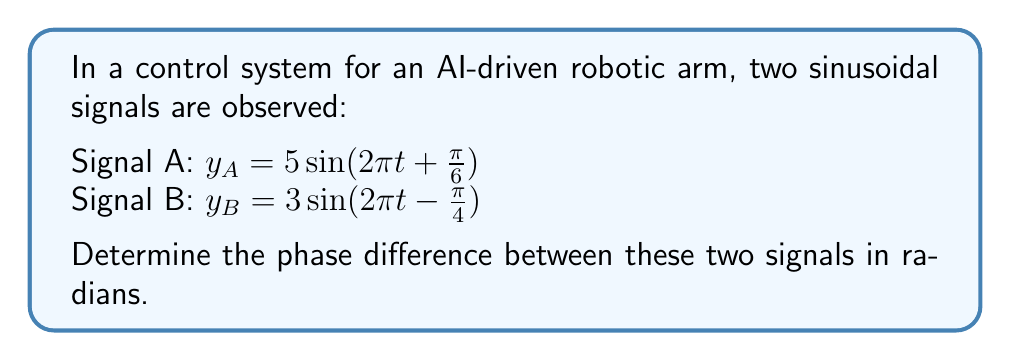Show me your answer to this math problem. To find the phase difference between two sinusoidal signals, we need to compare their phase angles. The general form of a sinusoidal signal is:

$y = A\sin(\omega t + \phi)$

Where $\phi$ is the phase angle.

For Signal A: $\phi_A = \frac{\pi}{6}$
For Signal B: $\phi_B = -\frac{\pi}{4}$

The phase difference is calculated by subtracting the phase angle of Signal B from Signal A:

$$\Delta\phi = \phi_A - \phi_B$$

$$\Delta\phi = \frac{\pi}{6} - (-\frac{\pi}{4})$$

$$\Delta\phi = \frac{\pi}{6} + \frac{\pi}{4}$$

To add these fractions, we need a common denominator:

$$\Delta\phi = \frac{2\pi}{12} + \frac{3\pi}{12}$$

$$\Delta\phi = \frac{5\pi}{12}$$

This is the phase difference in radians.
Answer: $\frac{5\pi}{12}$ radians 